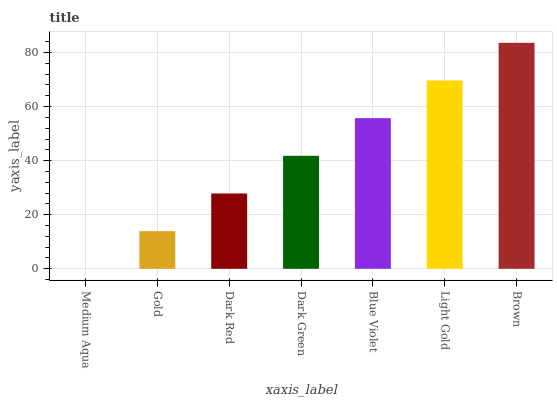Is Medium Aqua the minimum?
Answer yes or no. Yes. Is Brown the maximum?
Answer yes or no. Yes. Is Gold the minimum?
Answer yes or no. No. Is Gold the maximum?
Answer yes or no. No. Is Gold greater than Medium Aqua?
Answer yes or no. Yes. Is Medium Aqua less than Gold?
Answer yes or no. Yes. Is Medium Aqua greater than Gold?
Answer yes or no. No. Is Gold less than Medium Aqua?
Answer yes or no. No. Is Dark Green the high median?
Answer yes or no. Yes. Is Dark Green the low median?
Answer yes or no. Yes. Is Gold the high median?
Answer yes or no. No. Is Blue Violet the low median?
Answer yes or no. No. 